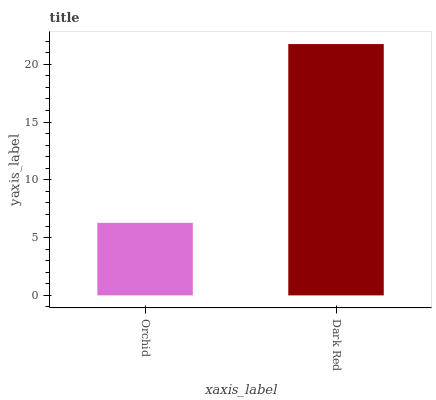Is Dark Red the minimum?
Answer yes or no. No. Is Dark Red greater than Orchid?
Answer yes or no. Yes. Is Orchid less than Dark Red?
Answer yes or no. Yes. Is Orchid greater than Dark Red?
Answer yes or no. No. Is Dark Red less than Orchid?
Answer yes or no. No. Is Dark Red the high median?
Answer yes or no. Yes. Is Orchid the low median?
Answer yes or no. Yes. Is Orchid the high median?
Answer yes or no. No. Is Dark Red the low median?
Answer yes or no. No. 